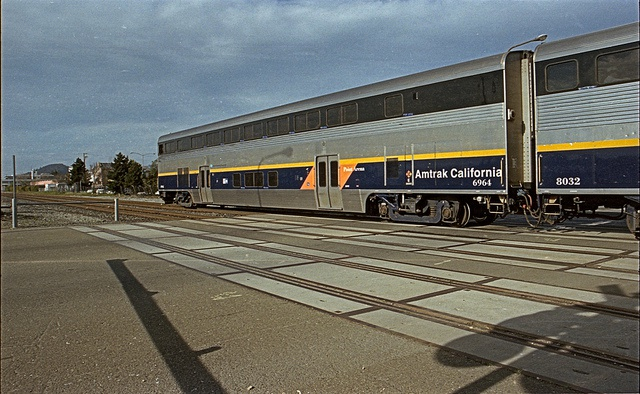Describe the objects in this image and their specific colors. I can see a train in black, gray, and darkgray tones in this image. 